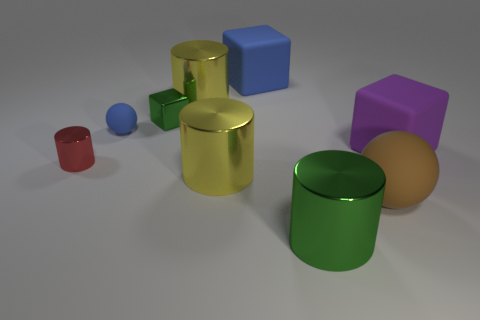What number of matte blocks are there?
Make the answer very short. 2. What shape is the shiny object that is both to the right of the tiny metal cube and behind the tiny cylinder?
Make the answer very short. Cylinder. Is the color of the big matte block that is on the right side of the big sphere the same as the cylinder behind the purple thing?
Make the answer very short. No. The matte cube that is the same color as the small ball is what size?
Offer a very short reply. Large. Are there any yellow cylinders that have the same material as the small blue sphere?
Your response must be concise. No. Is the number of small red metal cylinders in front of the big brown ball the same as the number of rubber objects right of the purple cube?
Offer a very short reply. Yes. What size is the red thing that is in front of the small blue ball?
Give a very brief answer. Small. There is a yellow cylinder behind the cube that is in front of the tiny green metallic cube; what is it made of?
Ensure brevity in your answer.  Metal. There is a metal cylinder that is on the right side of the blue object that is behind the small green block; what number of large objects are in front of it?
Provide a short and direct response. 0. Are the big cylinder on the right side of the large blue cube and the sphere behind the tiny red cylinder made of the same material?
Your response must be concise. No. 